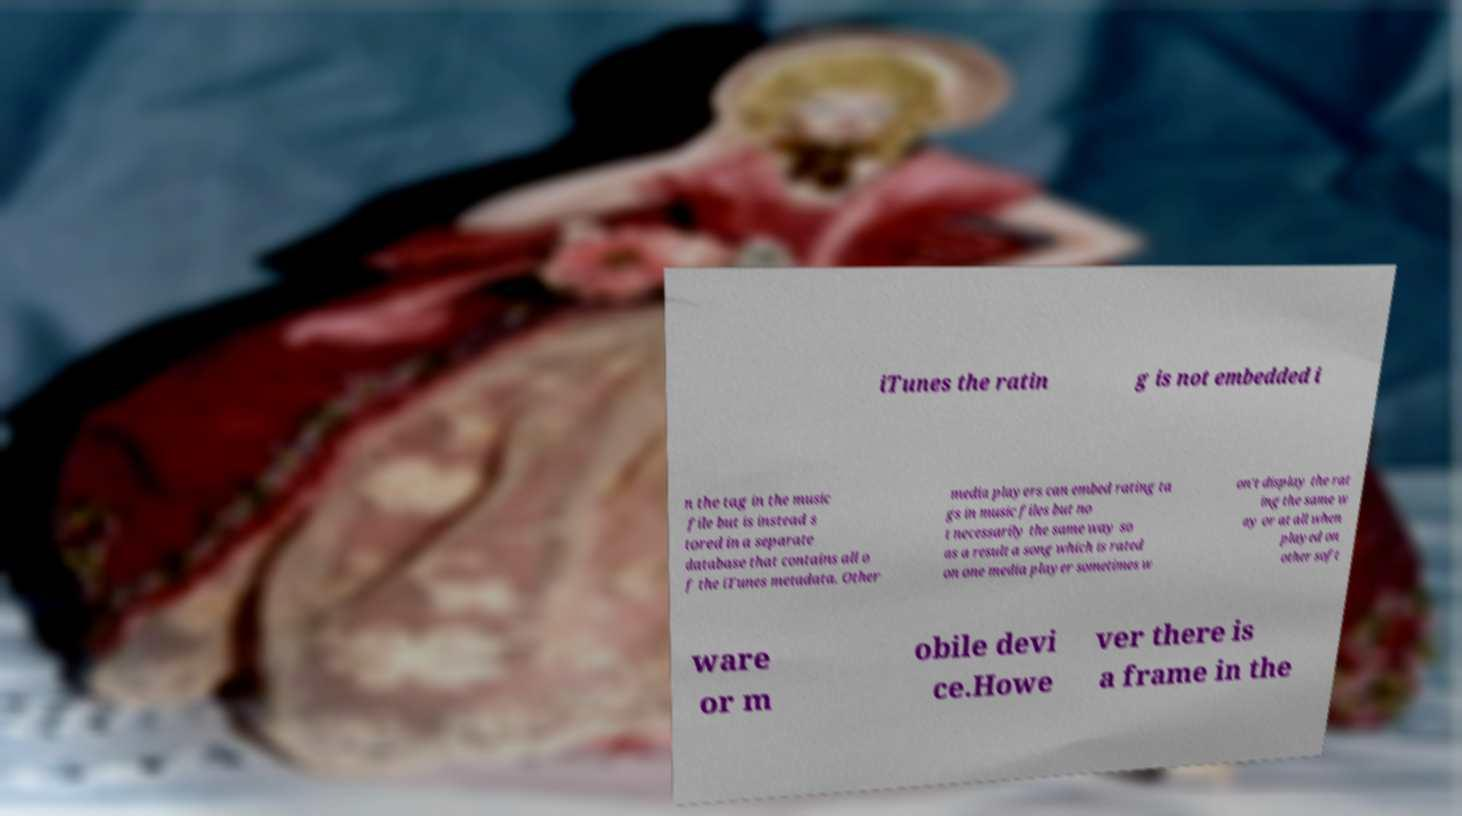What messages or text are displayed in this image? I need them in a readable, typed format. iTunes the ratin g is not embedded i n the tag in the music file but is instead s tored in a separate database that contains all o f the iTunes metadata. Other media players can embed rating ta gs in music files but no t necessarily the same way so as a result a song which is rated on one media player sometimes w on't display the rat ing the same w ay or at all when played on other soft ware or m obile devi ce.Howe ver there is a frame in the 